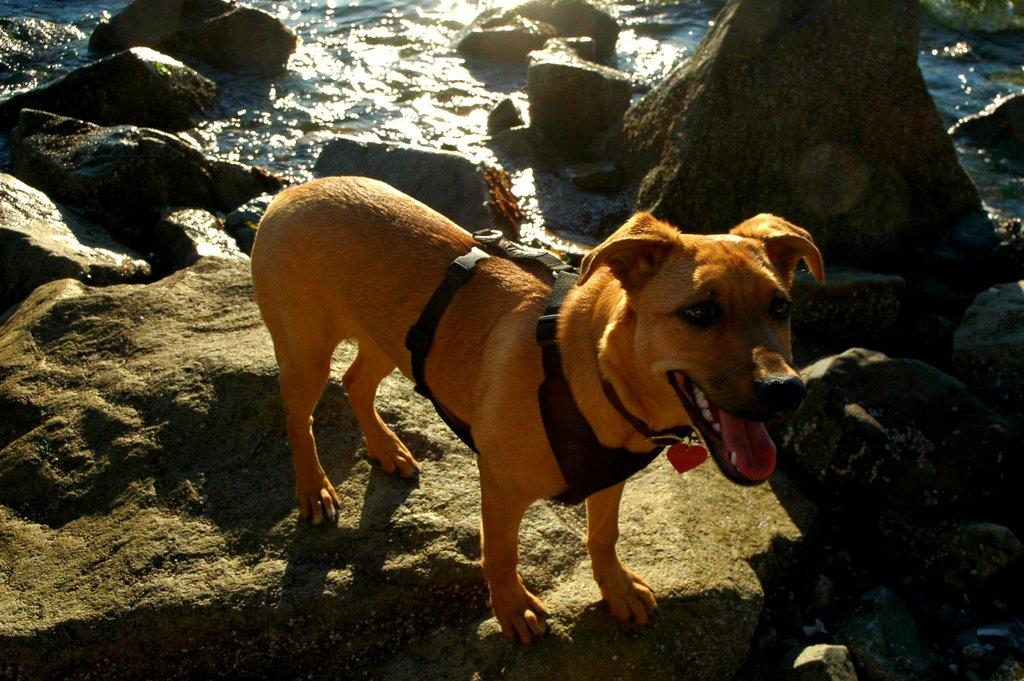What animal is present in the image? There is a dog in the image. Where is the dog located? The dog is on a rock. What can be seen in the background of the image? There is water visible in the background of the image. What type of yoke is the dog using to pull a cart in the image? There is no cart or yoke present in the image; it features a dog on a rock with water visible in the background. 